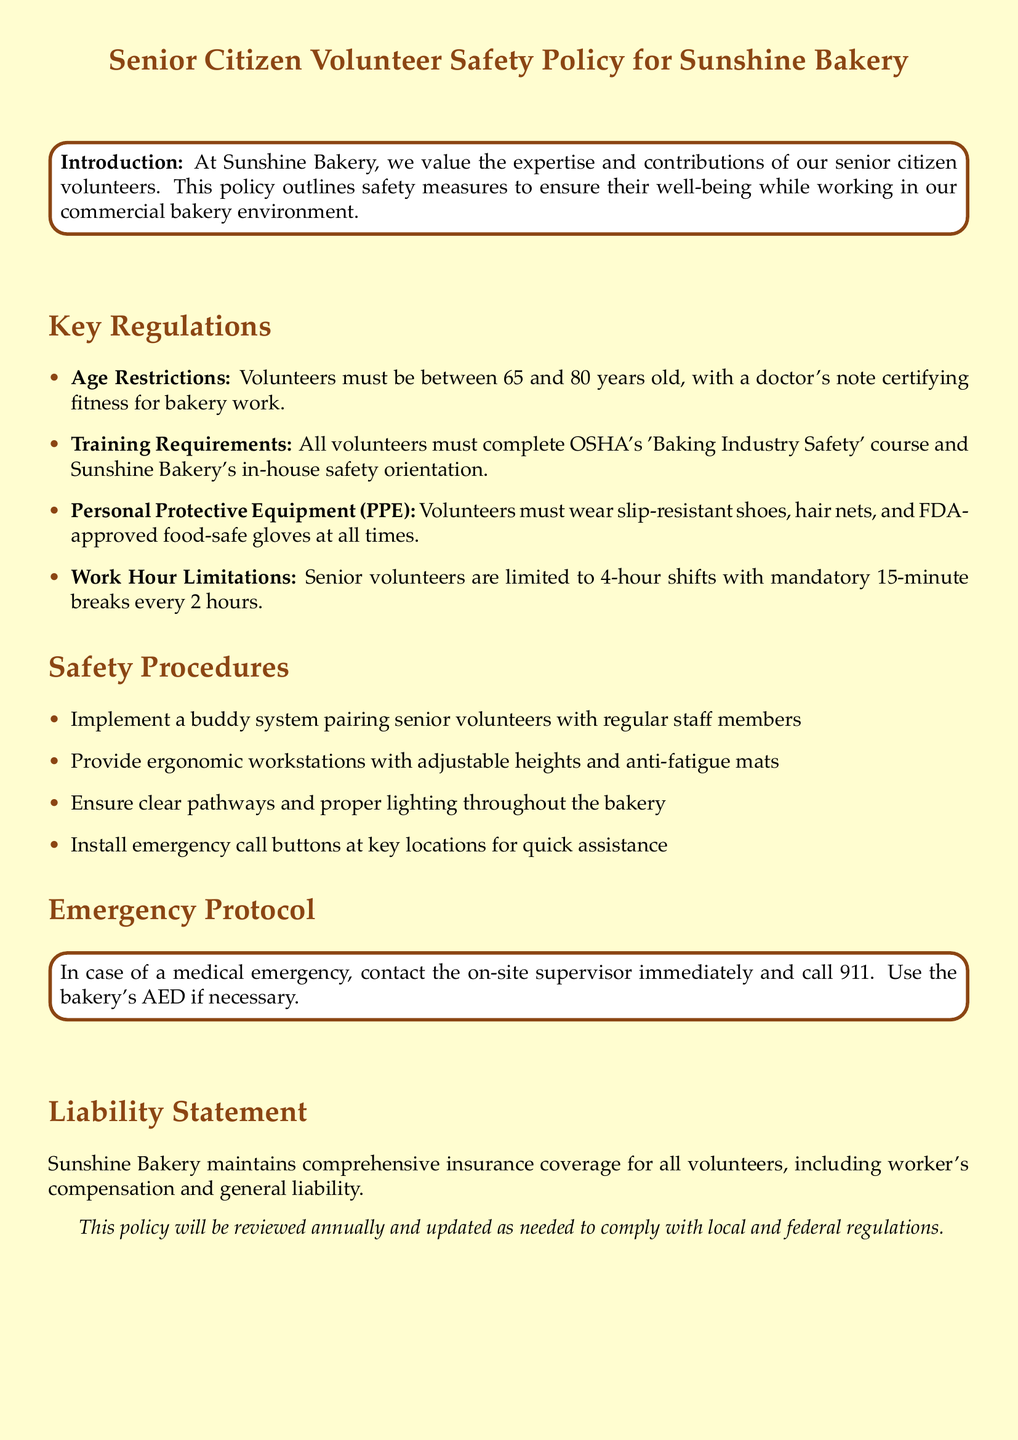What is the maximum age for volunteers? The maximum age for volunteers is specified as 80 years old in the age restrictions.
Answer: 80 years old What course must volunteers complete? Volunteers are required to complete the OSHA's 'Baking Industry Safety' course as mentioned in the training requirements.
Answer: OSHA's 'Baking Industry Safety' What type of shoes must volunteers wear? The document states that volunteers must wear slip-resistant shoes as part of the personal protective equipment requirements.
Answer: Slip-resistant shoes How long is each volunteer shift limited to? The work hour limitations specify that senior volunteers are limited to 4-hour shifts.
Answer: 4 hours What is the purpose of the buddy system? The buddy system is implemented to pair senior volunteers with regular staff members for safety support.
Answer: Safety support What is the response in case of a medical emergency? The emergency protocol indicates to contact the on-site supervisor and call 911 in case of medical emergencies.
Answer: Call 911 What insurance coverage does Sunshine Bakery maintain? The bakery maintains comprehensive insurance coverage for all volunteers, including worker's compensation and general liability.
Answer: Worker’s compensation and general liability How often will the policy be reviewed? The document states the policy will be reviewed annually to ensure compliance.
Answer: Annually 